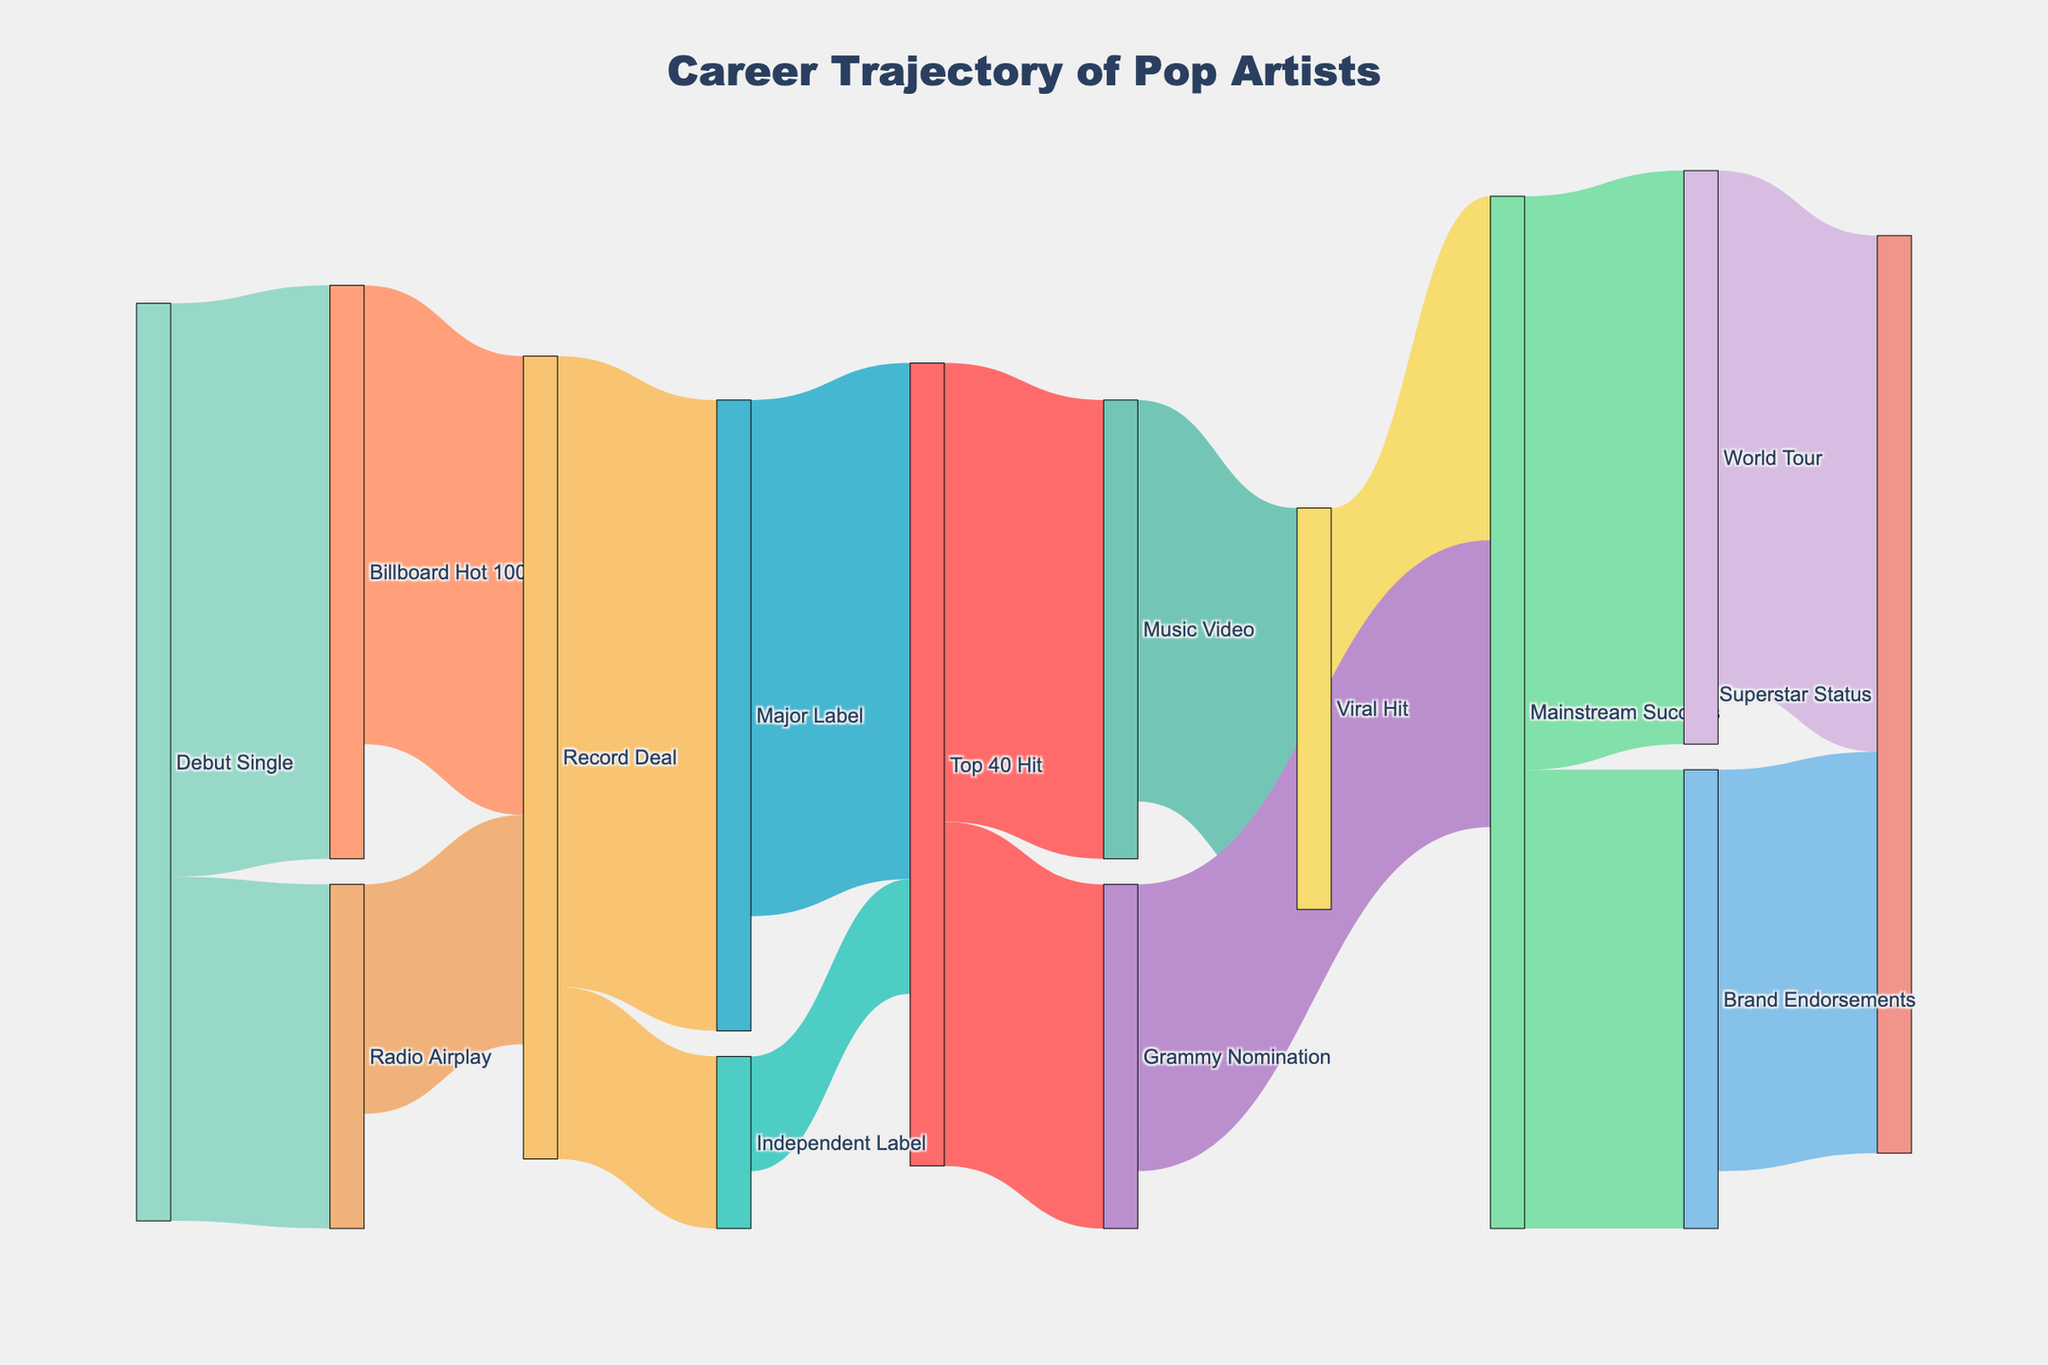Which label seems to be more popular, Major or Independent? By looking at the node sizes and link values, more record deals transition to Major Labels (550,000) compared to Independent Labels (150,000). Thus, Major Labels are more popular.
Answer: Major Labels What is the total number of pop artists that achieved mainstream success from their Grammy nominations? We look at the link from Grammy Nominations to Mainstream Success. The value of this link is 250,000. Therefore, 250,000 pop artists achieved mainstream success from their Grammy nominations.
Answer: 250,000 How many pop artists reached Superstar Status through Brand Endorsements? From the link between Brand Endorsements and Superstar Status, we can see that this path has a value of 350,000. So 350,000 pop artists reached Superstar Status through Brand Endorsements.
Answer: 350,000 What's the combined value of pop artists reaching a Record Deal through both Billboard Hot 100 and Radio Airplay? Adding the link values of Billboard Hot 100 to Record Deal (400,000) and Radio Airplay to Record Deal (200,000) gives us 600,000.
Answer: 600,000 Which pathway contributes more to Mainstream Success, Grammy Nominations or Viral Hit Music Videos? To compare, look at the link values: Grammy Nominations to Mainstream Success is 250,000, and Viral Hit to Mainstream Success is 300,000. Viral Hit contributes more to Mainstream Success.
Answer: Viral Hit Music Videos How many pop artists generated a Top 40 Hit while being signed with a Major Label? The link value between Major Label and Top 40 Hit is 450,000, meaning 450,000 pop artists achieved a Top 40 Hit while signed with a Major Label.
Answer: 450,000 From debut single, how many pop artists ended up signing a Record Deal through both Billboard Hot 100 and Radio Airplay collectively? We need to track both paths from debut single: Billboard Hot 100 to Record Deal (400,000) and Radio Airplay to Record Deal (200,000). The total is 400,000 + 200,000 = 600,000.
Answer: 600,000 What is the total number of pop artists who went from Debut Single to Billboard Hot 100? The direct link from Debut Single to Billboard Hot 100 has a value of 500,000. Hence, 500,000 pop artists transitioned from Debut Single to Billboard Hot 100.
Answer: 500,000 What's the sum of pop artists who achieved either Music Video or Grammy Nomination from a Top 40 Hit? Sum the values of links from Top 40 Hit to Music Video (400,000) and Top 40 Hit to Grammy Nomination (300,000). Total is 400,000 + 300,000 = 700,000.
Answer: 700,000 